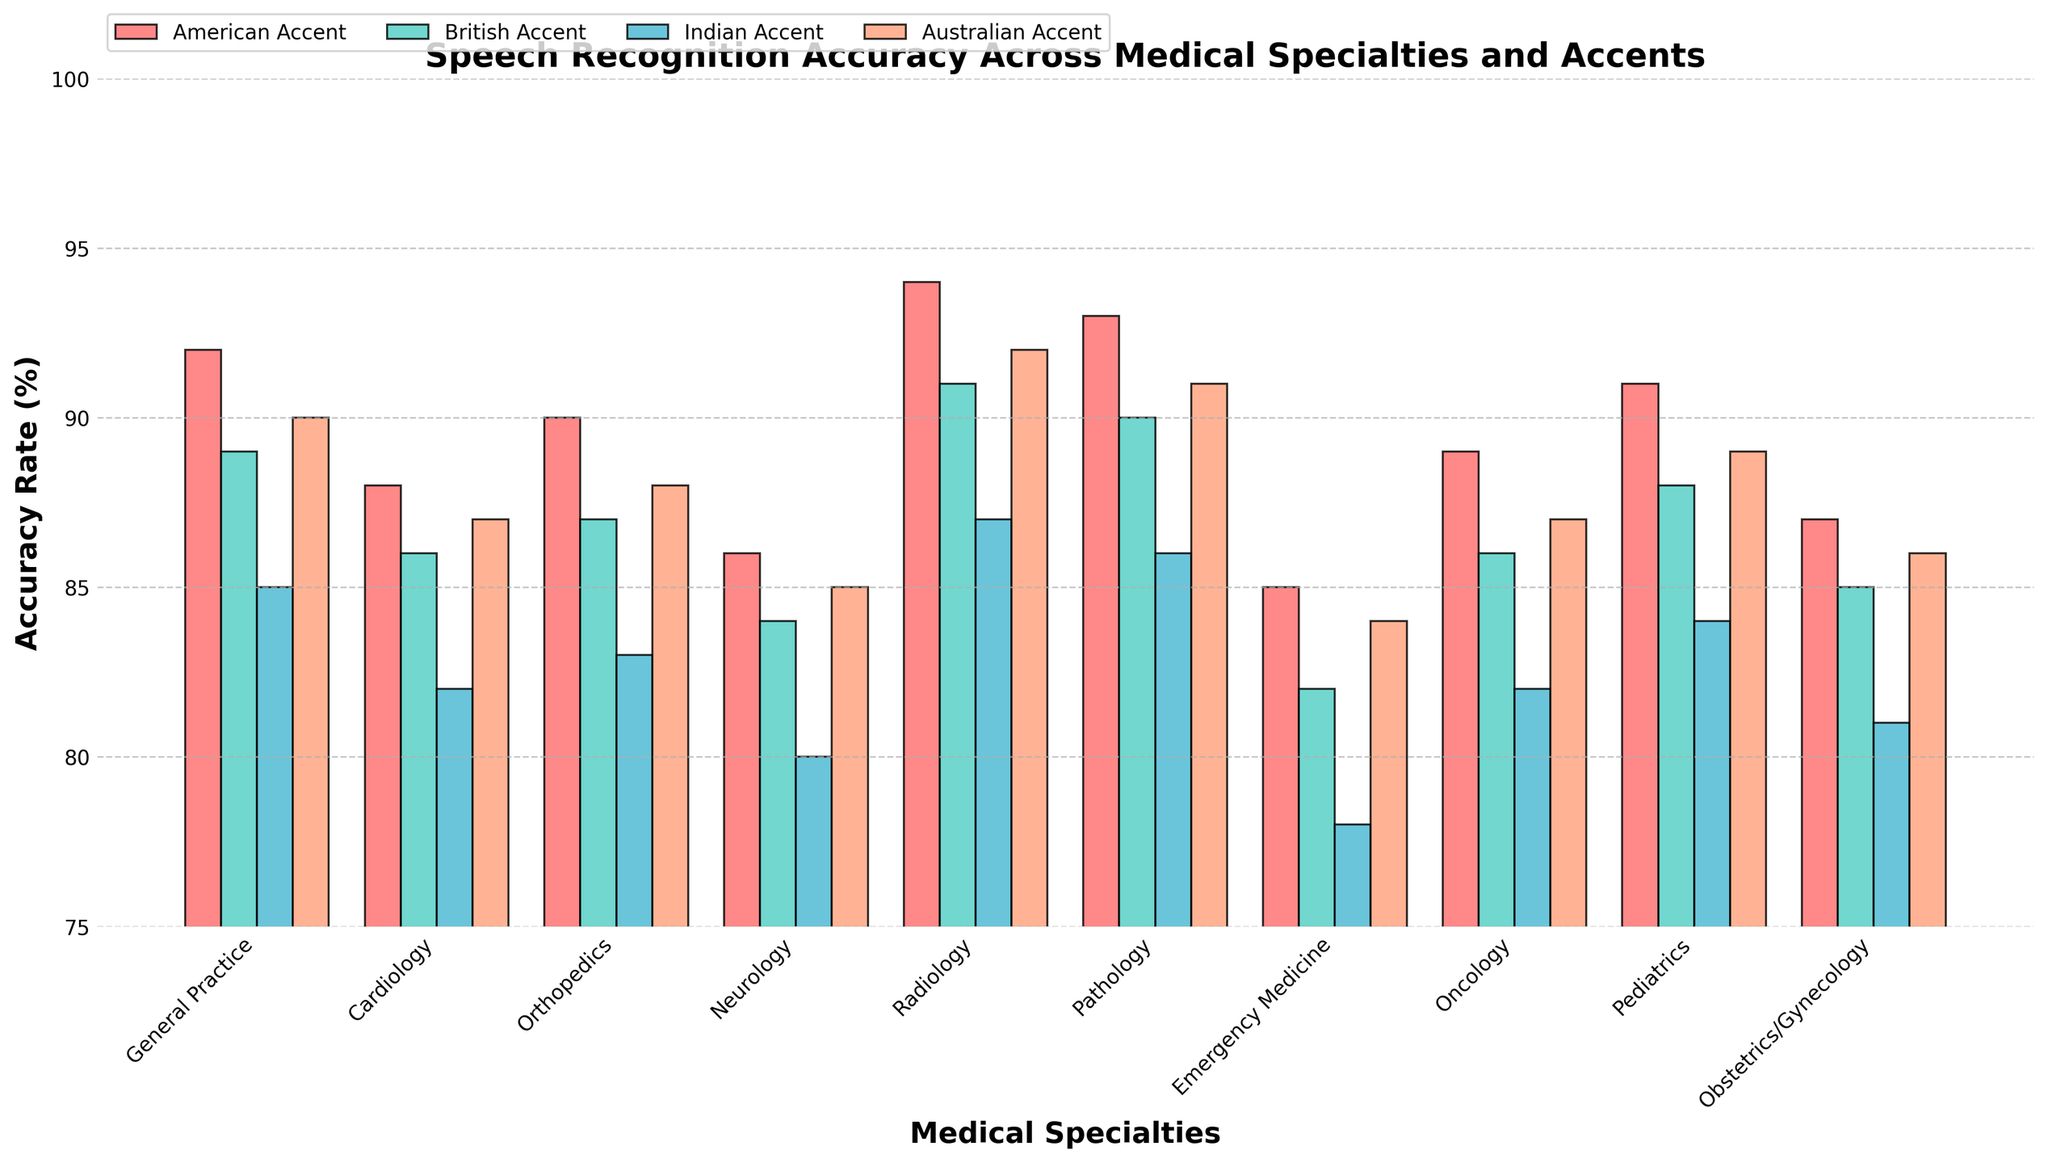Which specialty has the highest accuracy rate for American Accent? Look at the bars corresponding to the American Accent for all specialties and identify the one with the highest bar. Radiology has the highest accuracy rate.
Answer: Radiology Compare the accuracy rates for Indian Accent in General Practice and Neurology; which one is higher? Look at the bars for Indian Accent in General Practice and Neurology, and compare their heights. Indian Accent in General Practice has a higher accuracy rate compared to Neurology.
Answer: General Practice What is the average accuracy rate for British Accent across all specialties? Calculate the sum of the accuracy rates for British Accent (89, 86, 87, 84, 91, 90, 82, 86, 88, 85) and then divide by the number of specialties (10). The sum is 868, so the average is 868/10.
Answer: 86.8 Which accent shows the most consistent accuracy rate across all specialties? Evaluate the variability of the height of the bars for each accent across all specialties. The American Accent bars appear to be the most consistent, staying mostly in the range from 85 to 94.
Answer: American Accent What is the difference in accuracy rates between Pathology and Emergency Medicine for Australian Accent? Check the heights of the corresponding bars for Australian Accent in Pathology and Emergency Medicine. Pathology is 91, and Emergency Medicine is 84. The difference is 91 - 84.
Answer: 7 Identify the specialty with the largest gap in accuracy rates between the highest and lowest scoring accents. What is this gap? For each specialty, determine the highest and lowest bars and calculate the difference. For Neurology: American (86) and Indian (80), the gap is 6. This is the largest gap.
Answer: Neurology, 6 Between Oncology and Obstetrics/Gynecology, which specialty has a higher accuracy rate for British Accent? Compare the bars for British Accent for Oncology and Obstetrics/Gynecology. Oncology has 86, and Obstetrics/Gynecology has 85.
Answer: Oncology What is the combined accuracy rate of General Practice for all accents? Sum the accuracy rates for General Practice across all accents: American (92), British (89), Indian (85), and Australian (90). The combined rate is 92 + 89 + 85 + 90.
Answer: 356 How does the accuracy rate of Pediatrics for Indian Accent compare to the average accuracy rate of all accents in Pediatrics? Calculate the average accuracy rate for Pediatrics across all accents: (91, 88, 84, 89)/4 = 88. The rate for Indian Accent is 84. Compare 84 with 88.
Answer: Lower Which accent has the lowest overall accuracy rate for all specialties combined? Sum up the accuracy rates for each accent across all specialties and find the lowest sum. Indian Accent: 873, Australian Accent: 882, British Accent: 868, American Accent: 895. The lowest is British Accent.
Answer: British Accent 